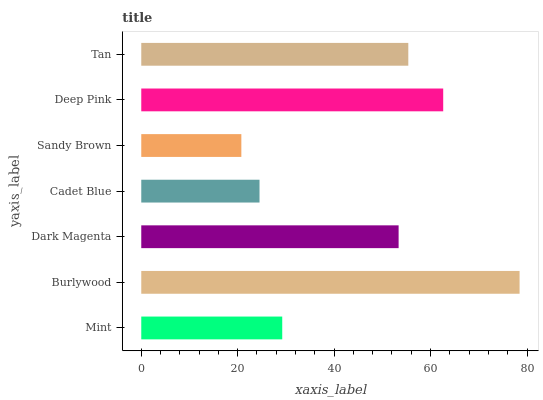Is Sandy Brown the minimum?
Answer yes or no. Yes. Is Burlywood the maximum?
Answer yes or no. Yes. Is Dark Magenta the minimum?
Answer yes or no. No. Is Dark Magenta the maximum?
Answer yes or no. No. Is Burlywood greater than Dark Magenta?
Answer yes or no. Yes. Is Dark Magenta less than Burlywood?
Answer yes or no. Yes. Is Dark Magenta greater than Burlywood?
Answer yes or no. No. Is Burlywood less than Dark Magenta?
Answer yes or no. No. Is Dark Magenta the high median?
Answer yes or no. Yes. Is Dark Magenta the low median?
Answer yes or no. Yes. Is Burlywood the high median?
Answer yes or no. No. Is Cadet Blue the low median?
Answer yes or no. No. 